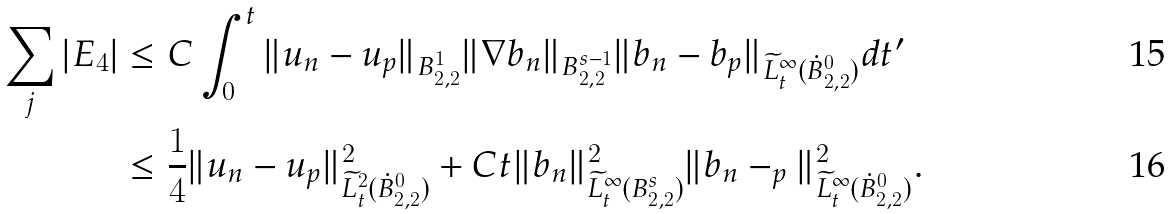Convert formula to latex. <formula><loc_0><loc_0><loc_500><loc_500>\sum _ { j } | E _ { 4 } | & \leq C \int _ { 0 } ^ { t } \| u _ { n } - u _ { p } \| _ { B ^ { 1 } _ { 2 , 2 } } \| \nabla b _ { n } \| _ { B ^ { s - 1 } _ { 2 , 2 } } \| b _ { n } - b _ { p } \| _ { \widetilde { L } ^ { \infty } _ { t } ( \dot { B } ^ { 0 } _ { 2 , 2 } ) } d t ^ { \prime } \\ & \leq \frac { 1 } { 4 } \| u _ { n } - u _ { p } \| ^ { 2 } _ { \widetilde { L } ^ { 2 } _ { t } ( \dot { B } ^ { 0 } _ { 2 , 2 } ) } + C t \| b _ { n } \| ^ { 2 } _ { \widetilde { L } ^ { \infty } _ { t } ( B ^ { s } _ { 2 , 2 } ) } \| b _ { n } - _ { p } \| ^ { 2 } _ { \widetilde { L } ^ { \infty } _ { t } ( \dot { B } ^ { 0 } _ { 2 , 2 } ) } .</formula> 